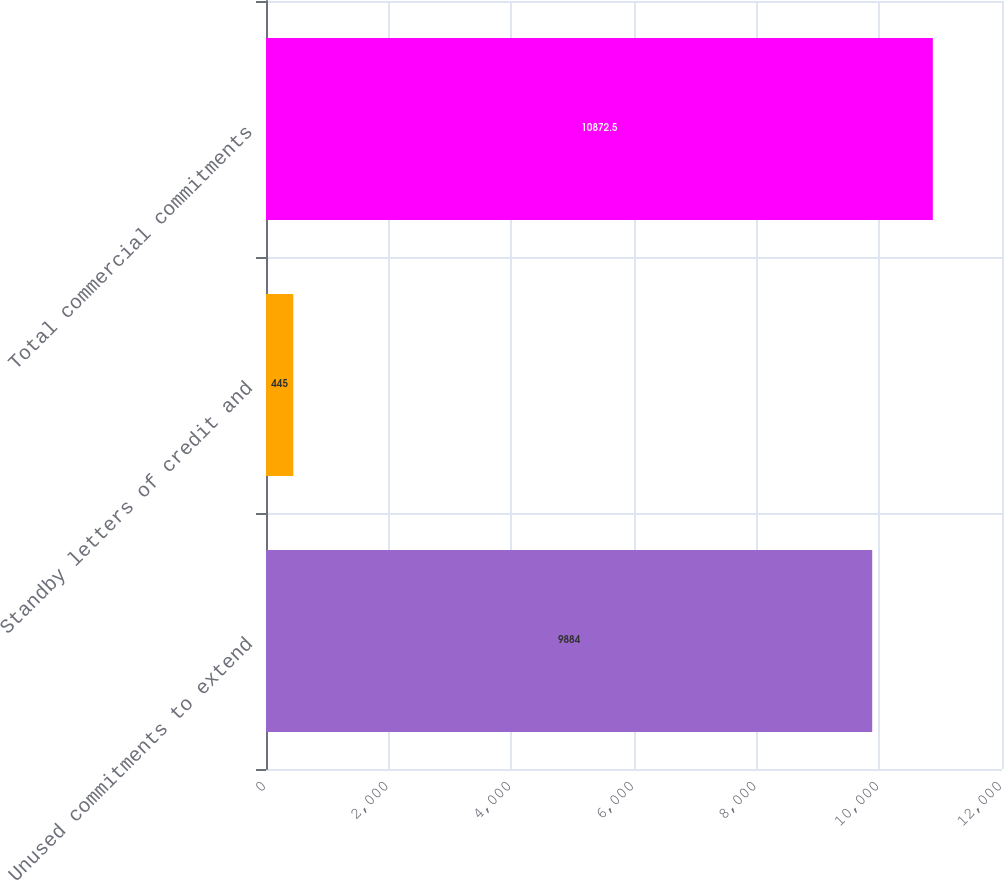<chart> <loc_0><loc_0><loc_500><loc_500><bar_chart><fcel>Unused commitments to extend<fcel>Standby letters of credit and<fcel>Total commercial commitments<nl><fcel>9884<fcel>445<fcel>10872.5<nl></chart> 